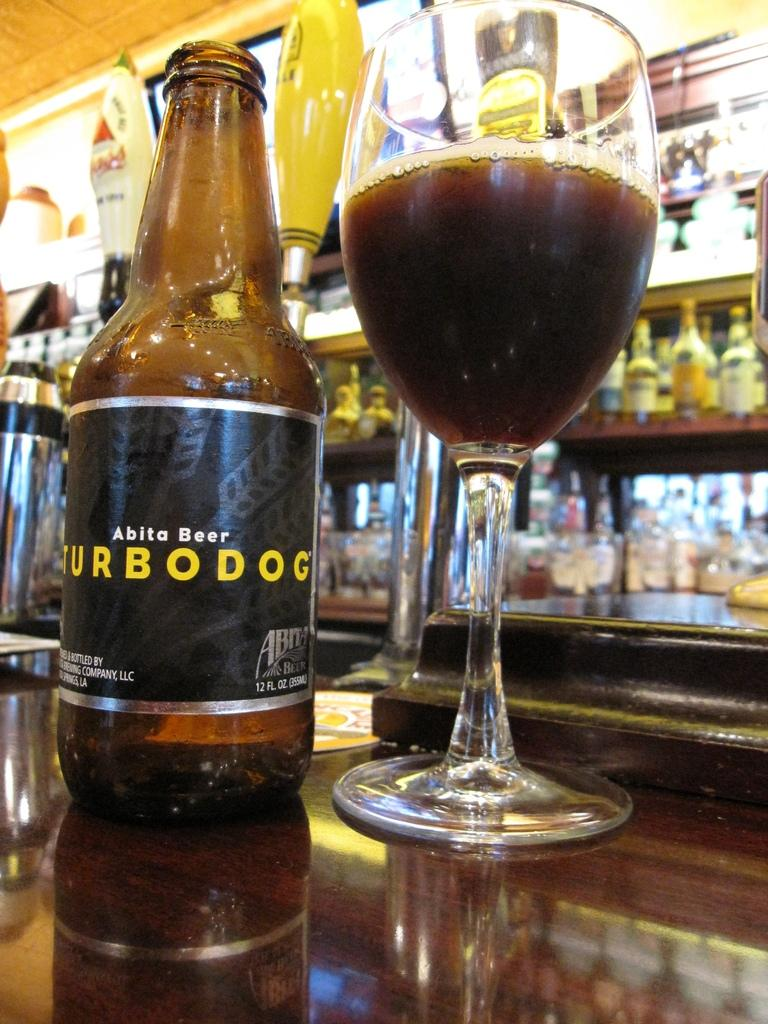What type of alcoholic beverages are present in the image? There is a beer bottle and a wine glass in the image. Where are the beer bottle and wine glass located? Both the beer bottle and wine glass are placed on a table. What can be seen in the background of the image? There are bottles placed in a rack in the background of the image. Can you describe the yellow object visible behind the beer bottle? There is a yellow object visible behind the beer bottle, but its exact nature cannot be determined from the image. What type of chain is being used to hold the cherry in the image? There is no chain or cherry present in the image. 